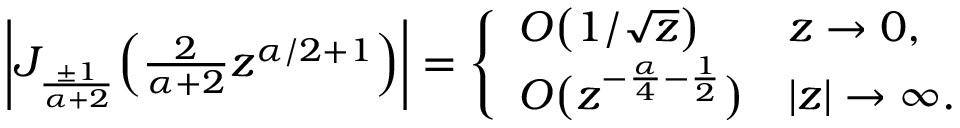Convert formula to latex. <formula><loc_0><loc_0><loc_500><loc_500>\begin{array} { r } { \left | J _ { \frac { \pm 1 } { \alpha + 2 } } \left ( \frac { 2 } { \alpha + 2 } z ^ { \alpha / 2 + 1 } \right ) \right | = \left \{ \begin{array} { l l } { O \left ( 1 / \sqrt { z } \right ) } & { z \rightarrow 0 , } \\ { O \left ( z ^ { - \frac { \alpha } { 4 } - \frac { 1 } { 2 } } \right ) } & { | z | \rightarrow \infty . } \end{array} } \end{array}</formula> 